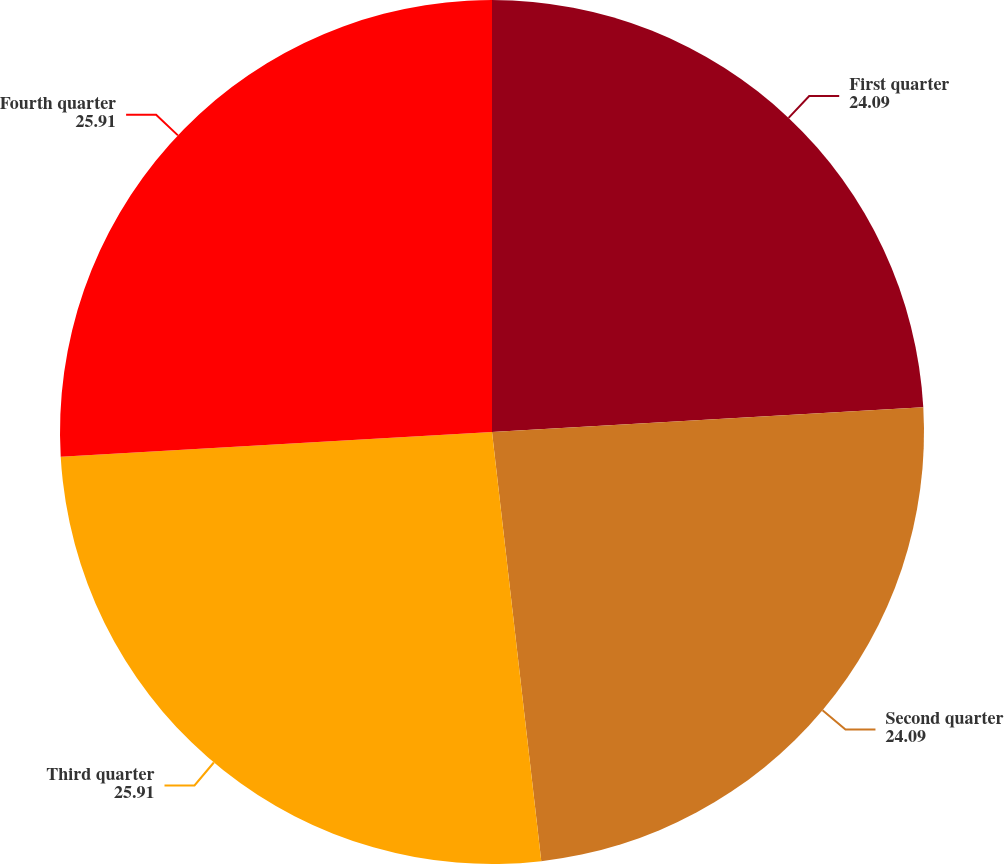Convert chart. <chart><loc_0><loc_0><loc_500><loc_500><pie_chart><fcel>First quarter<fcel>Second quarter<fcel>Third quarter<fcel>Fourth quarter<nl><fcel>24.09%<fcel>24.09%<fcel>25.91%<fcel>25.91%<nl></chart> 